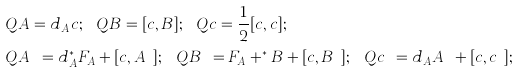Convert formula to latex. <formula><loc_0><loc_0><loc_500><loc_500>& Q A = d _ { A } c ; \ \ Q B = [ c , B ] ; \ \ Q c = \frac { 1 } { 2 } [ c , c ] ; \\ & Q A ^ { \dag } = d _ { A } ^ { * } F _ { A } + [ c , A ^ { \dag } ] ; \ \ Q B ^ { \dag } = F _ { A } + ^ { * } B + [ c , B ^ { \dag } ] ; \ \ Q c ^ { \dag } = d _ { A } A ^ { \dag } + [ c , c ^ { \dag } ] ;</formula> 